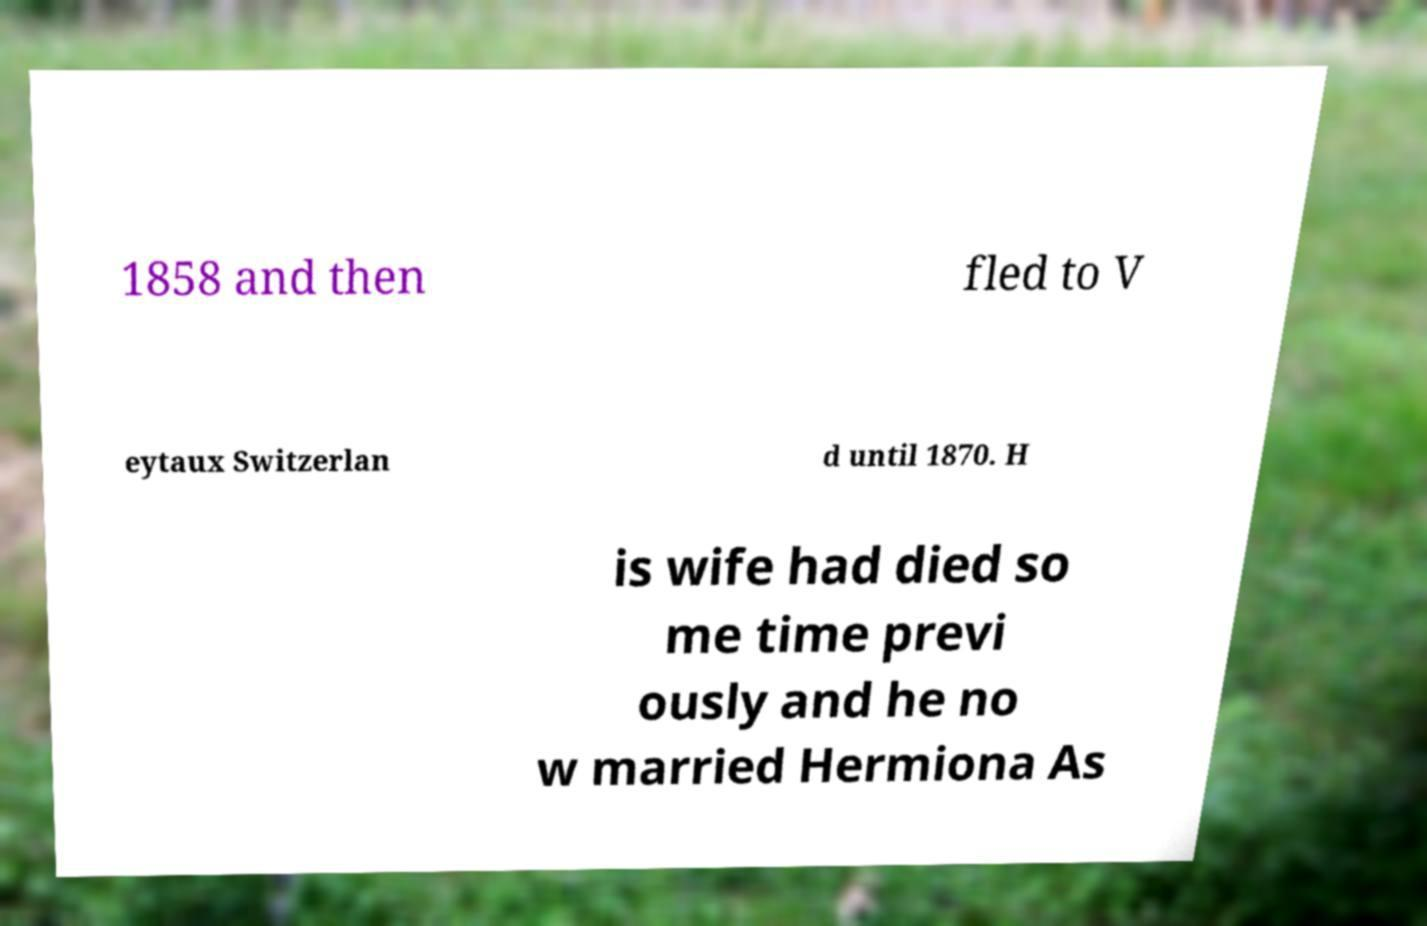Please identify and transcribe the text found in this image. 1858 and then fled to V eytaux Switzerlan d until 1870. H is wife had died so me time previ ously and he no w married Hermiona As 